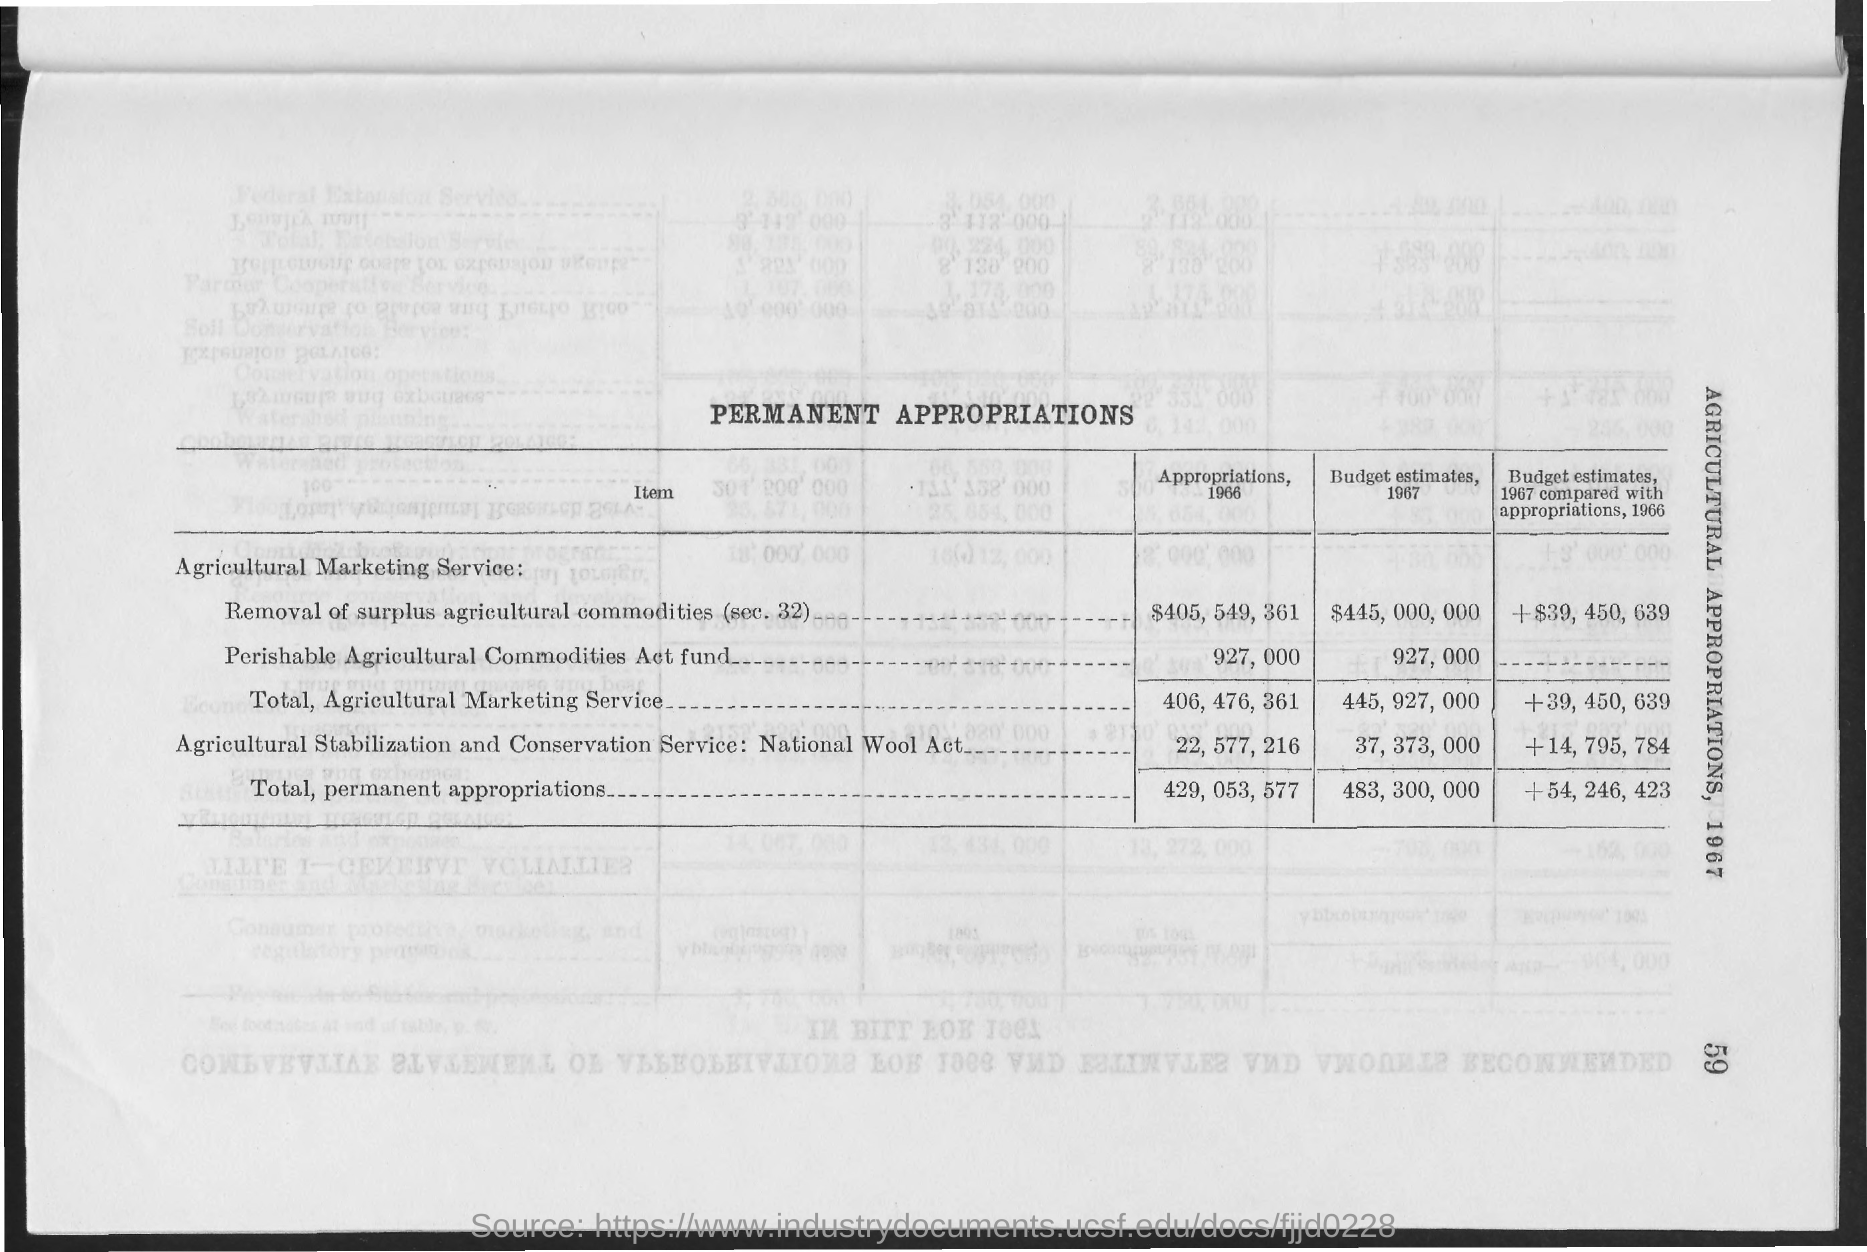What is the heading of the table ?
Keep it short and to the point. PERMANENT APPROPRIATIONS. What is the first column heading of the table ?
Provide a succinct answer. ITEM. 